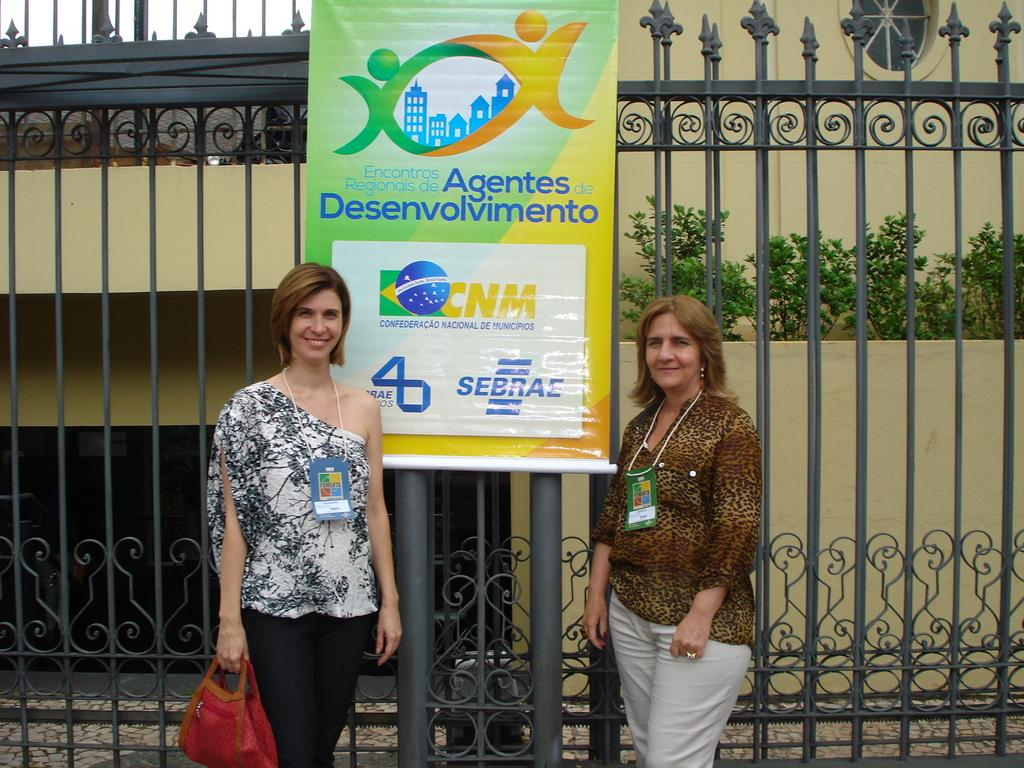How many women are in the image? There are two women in the image. What are the women wearing that is noticeable? Both women are wearing badges. What is one of the women holding? One of the women is holding a bag. What can be seen in the background of the image? There is a banner, a gate, a small plant, and a building in the background of the image. How many babies are being carried by the women in the image? There are no babies present in the image. What is the women's wish for the future, as depicted in the image? The image does not provide any information about the women's wishes for the future. 